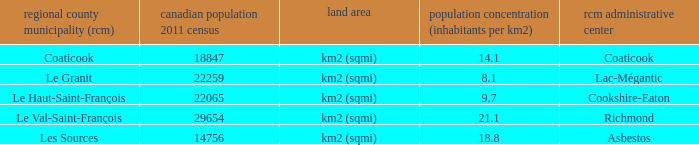What is the land area of the RCM having a density of 21.1? Km2 (sqmi). 